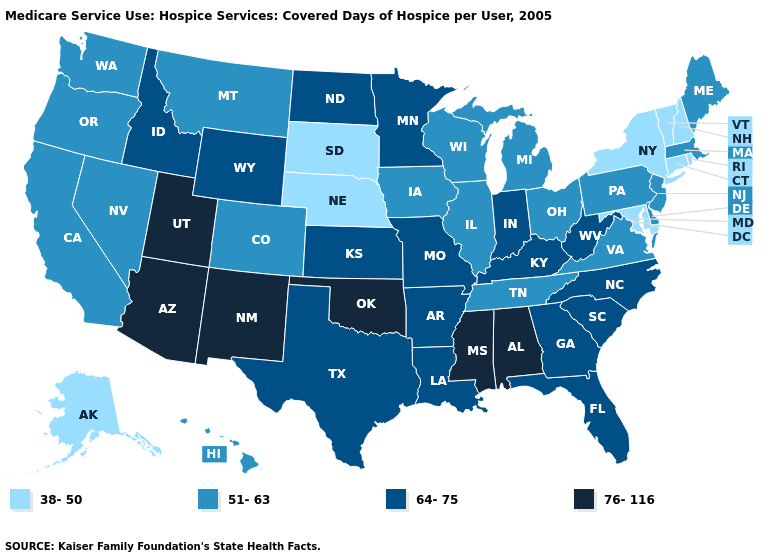Which states have the highest value in the USA?
Keep it brief. Alabama, Arizona, Mississippi, New Mexico, Oklahoma, Utah. Does Vermont have the same value as North Dakota?
Write a very short answer. No. Does the first symbol in the legend represent the smallest category?
Be succinct. Yes. What is the value of Idaho?
Short answer required. 64-75. What is the value of Washington?
Quick response, please. 51-63. Does Maryland have the lowest value in the South?
Concise answer only. Yes. Among the states that border Louisiana , does Mississippi have the lowest value?
Give a very brief answer. No. Among the states that border Ohio , which have the lowest value?
Be succinct. Michigan, Pennsylvania. Name the states that have a value in the range 51-63?
Write a very short answer. California, Colorado, Delaware, Hawaii, Illinois, Iowa, Maine, Massachusetts, Michigan, Montana, Nevada, New Jersey, Ohio, Oregon, Pennsylvania, Tennessee, Virginia, Washington, Wisconsin. Does Mississippi have the highest value in the USA?
Quick response, please. Yes. What is the value of Kansas?
Give a very brief answer. 64-75. Which states have the lowest value in the USA?
Answer briefly. Alaska, Connecticut, Maryland, Nebraska, New Hampshire, New York, Rhode Island, South Dakota, Vermont. Name the states that have a value in the range 51-63?
Be succinct. California, Colorado, Delaware, Hawaii, Illinois, Iowa, Maine, Massachusetts, Michigan, Montana, Nevada, New Jersey, Ohio, Oregon, Pennsylvania, Tennessee, Virginia, Washington, Wisconsin. Name the states that have a value in the range 51-63?
Answer briefly. California, Colorado, Delaware, Hawaii, Illinois, Iowa, Maine, Massachusetts, Michigan, Montana, Nevada, New Jersey, Ohio, Oregon, Pennsylvania, Tennessee, Virginia, Washington, Wisconsin. Name the states that have a value in the range 64-75?
Short answer required. Arkansas, Florida, Georgia, Idaho, Indiana, Kansas, Kentucky, Louisiana, Minnesota, Missouri, North Carolina, North Dakota, South Carolina, Texas, West Virginia, Wyoming. 